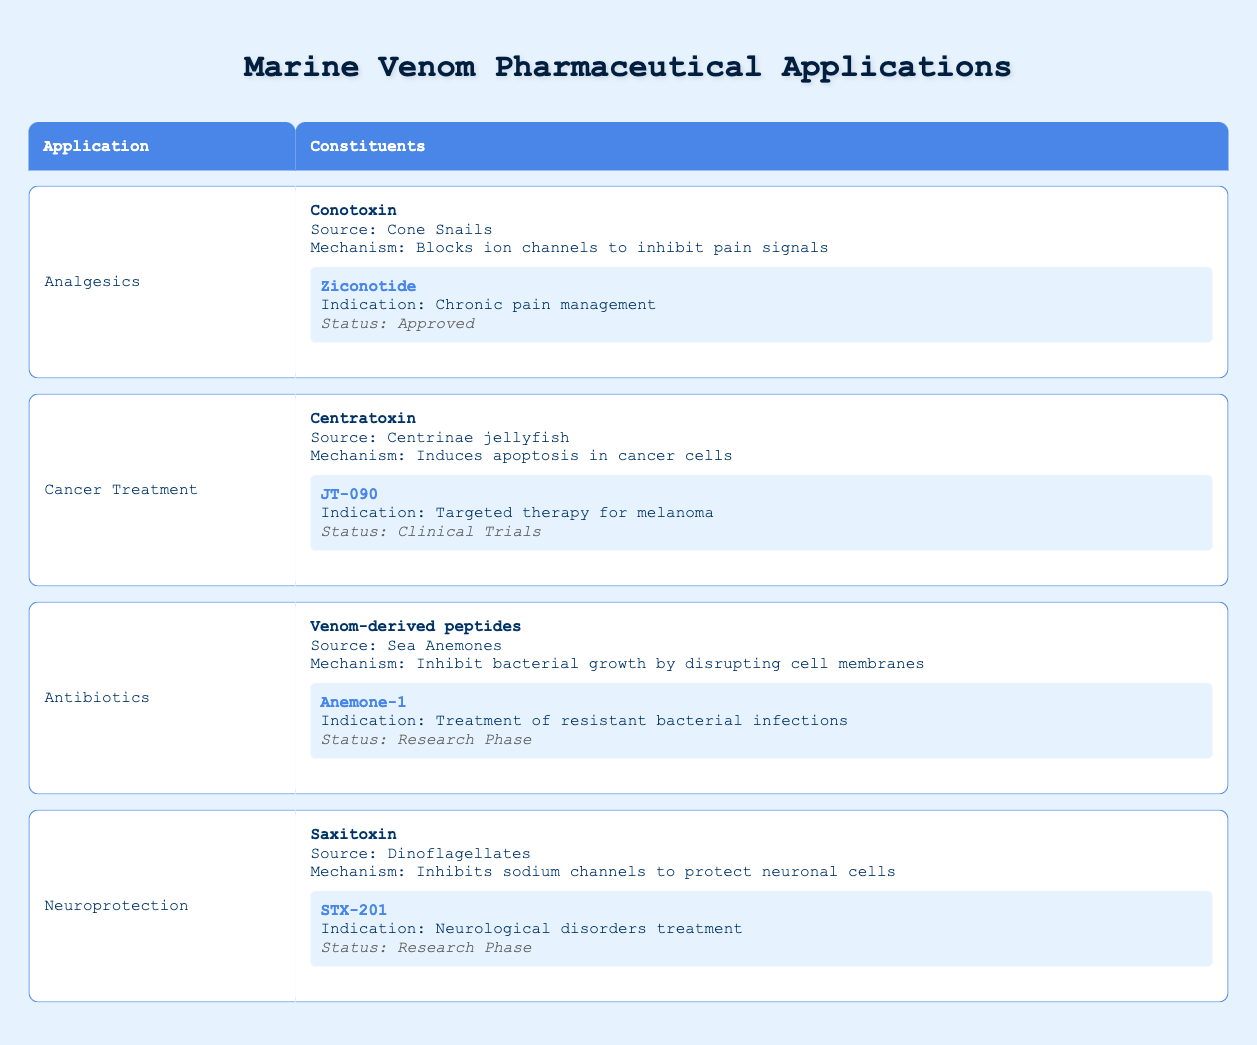What is the source of Conotoxin? According to the table, Conotoxin is sourced from Cone Snails.
Answer: Cone Snails Which application has a product in the Research Phase? The applications listed with products in the Research Phase include Antibiotics (Anemone-1) and Neuroprotection (STX-201).
Answer: Antibiotics, Neuroprotection What is the indication for Ziconotide? The table states that Ziconotide is indicated for chronic pain management.
Answer: Chronic pain management Is Centratoxin primarily used for pain management? The table indicates Centratoxin is used to induce apoptosis in cancer cells, not for pain management.
Answer: No How many different applications are presented in the table? Four distinct applications are mentioned: Analgesics, Cancer Treatment, Antibiotics, and Neuroprotection. Therefore, count them: 1, 2, 3, 4.
Answer: Four What is the mechanism of Saxitoxin? The table states that Saxitoxin inhibits sodium channels to protect neuronal cells, which is its mechanism.
Answer: Inhibits sodium channels to protect neuronal cells What are the example products for the application of Antibiotics? The table indicates that the product under the Antibiotics application is Anemone-1.
Answer: Anemone-1 Does the table provide any approved products? Upon reviewing the table, only Ziconotide is marked as approved, while the other products are either in clinical trials or research phases.
Answer: Yes What is the relationship between Centratoxin and cancer treatment? Centratoxin, sourced from Centrinae jellyfish, is associated with cancer treatment due to its mechanism of inducing apoptosis in cancer cells, specifically for melanoma with the product JT-090 currently in clinical trials.
Answer: Induces apoptosis in cancer cells 